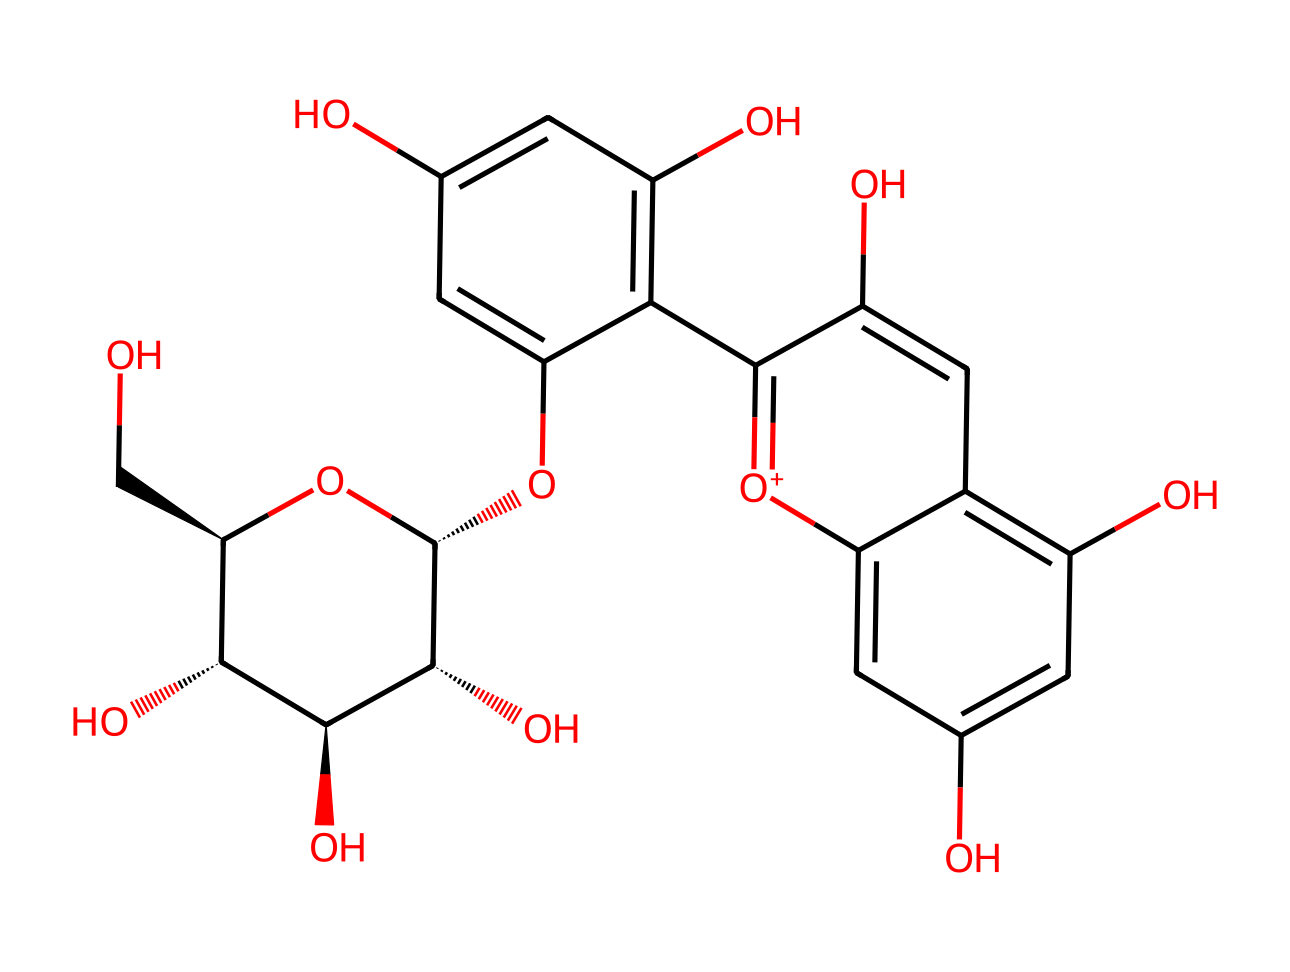What is the total number of carbon atoms in this flavonoid? Count the carbon atoms in the provided SMILES representation. Each "C" in the chemical structure indicates a carbon atom, and summing these gives a total of 21 carbon atoms.
Answer: 21 How many hydroxyl (OH) groups are present in the structure? Identify the instances of "O" followed by "C" in the structure, which denotes hydroxyl groups. Upon counting, there are 6 hydroxyl groups in total.
Answer: 6 What type of chemical structure does this represent? The presence of multiple hydroxyl groups and the specific arrangement of carbon rings signifies that this compound belongs to the class of flavonoids, which are known for their antioxidant properties.
Answer: flavonoid Is there a double bond in the structure? Looking through the chemical diagram, we notice "C=C" that indicates double bonds between carbon atoms. The presence of these double bonds is characteristic of flavonoids.
Answer: yes What is the significance of the oxygen atoms in this molecule? The oxygen atoms, particularly those in hydroxyl groups, contribute to the antioxidant activity of flavonoids. They can donate electrons, which help in neutralizing free radicals, thus showing their significance in health benefits.
Answer: antioxidant activity How many cyclic structures are present in this flavonoid? By analyzing the structure, it's evident that there are three cyclic rings formed by the carbon atoms, indicative of the basic flavonoid architecture characterized by two benzene rings and a heterocyclic ring.
Answer: 3 